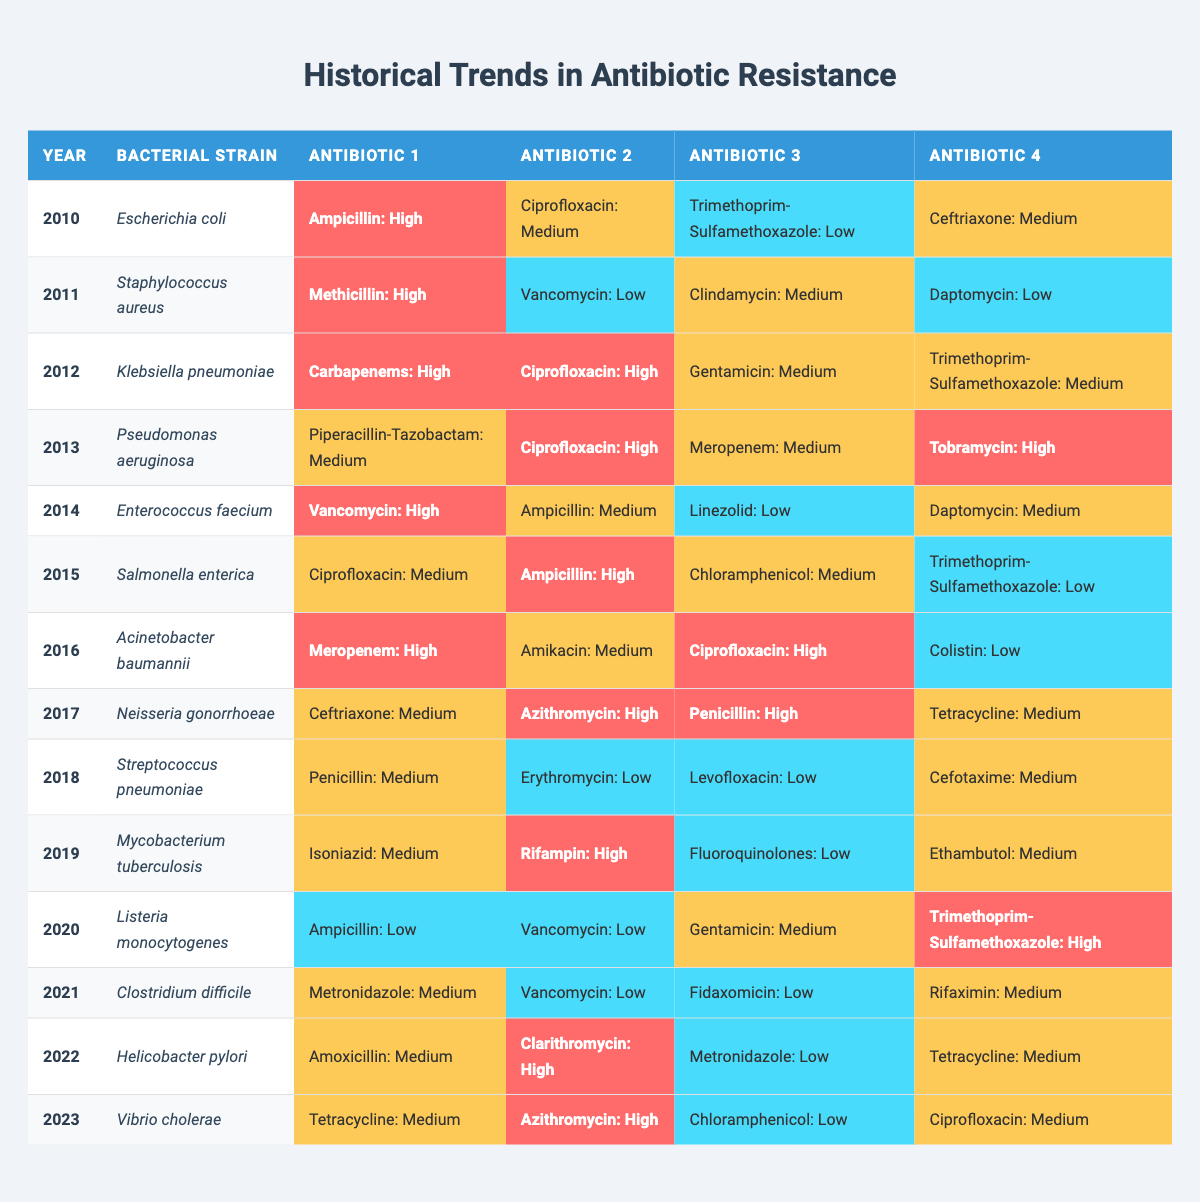What is the bacterial strain with the highest resistance level in 2012? In 2012, the strain Klebsiella pneumoniae has two antibiotics (Carbapenems and Ciprofloxacin) reported with a high resistance level.
Answer: Klebsiella pneumoniae Which antibiotic had a high resistance level for Neisseria gonorrhoeae in 2017? In 2017, the antibiotics Azithromycin and Penicillin were reported with a high resistance level for Neisseria gonorrhoeae.
Answer: Azithromycin and Penicillin How many different bacterial strains have shown a high resistance level to Ampicillin from 2010 to 2020? The strains Escherichia coli (2010), Salmonella enterica (2015), and Enterococcus faecium (2014) are noted for high resistance to Ampicillin. This gives a total of three strains.
Answer: 3 What was the resistance level of Trimethoprim-Sulfamethoxazole for Escherichia coli in 2010? The resistance level for Trimethoprim-Sulfamethoxazole in 2010 for Escherichia coli was noted as low.
Answer: Low Which bacterial strain had the lowest resistance level to Vancomycin in 2021? In 2021, Clostridium difficile was reported to have a low resistance level to Vancomycin, making it the lowest for that year.
Answer: Clostridium difficile Is there any bacterial strain with a high resistance level against Rifampin in the table? Yes, Mycobacterium tuberculosis was reported with a high resistance level against Rifampin in 2019.
Answer: Yes What patterns can be seen in the resistance levels of Tetracycline across the years? Tetracycline showed medium resistance in 2018 and 2023, and no other data points indicate high resistance levels, showing a trend without high values across the other years.
Answer: Medium resistance in 2018 and 2023 Calculate the average number of antibiotics with high resistance levels per year based on the data. In total, there are 11 instances of high resistance levels across the years recorded. Since there are 14 years, the average is 11/14 = 0.79.
Answer: 0.79 What was the resistance level of Ciprofloxacin for Acinetobacter baumannii in 2016? In 2016, Acinetobacter baumannii showed a high resistance level to Ciprofloxacin.
Answer: High Which year had the most bacterial strains reported with high resistance levels to antibiotics? The year 2012 had three different antibiotics (Carbapenems, Ciprofloxacin) with high resistance levels noted for Klebsiella pneumoniae.
Answer: 2012 